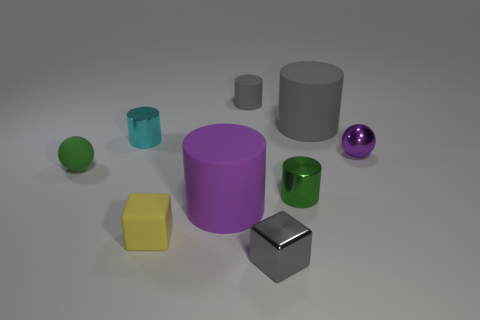Can you tell me the material properties of the objects in this image? Certainly! The objects appear to have different surface properties suggesting a variety of materials. The spheres and the cube have a reflective surface that suggests they are made of some sort of metal. The cylinders and the mug, by contrast, have a matte finish which may suggest a ceramic or plastic material. 